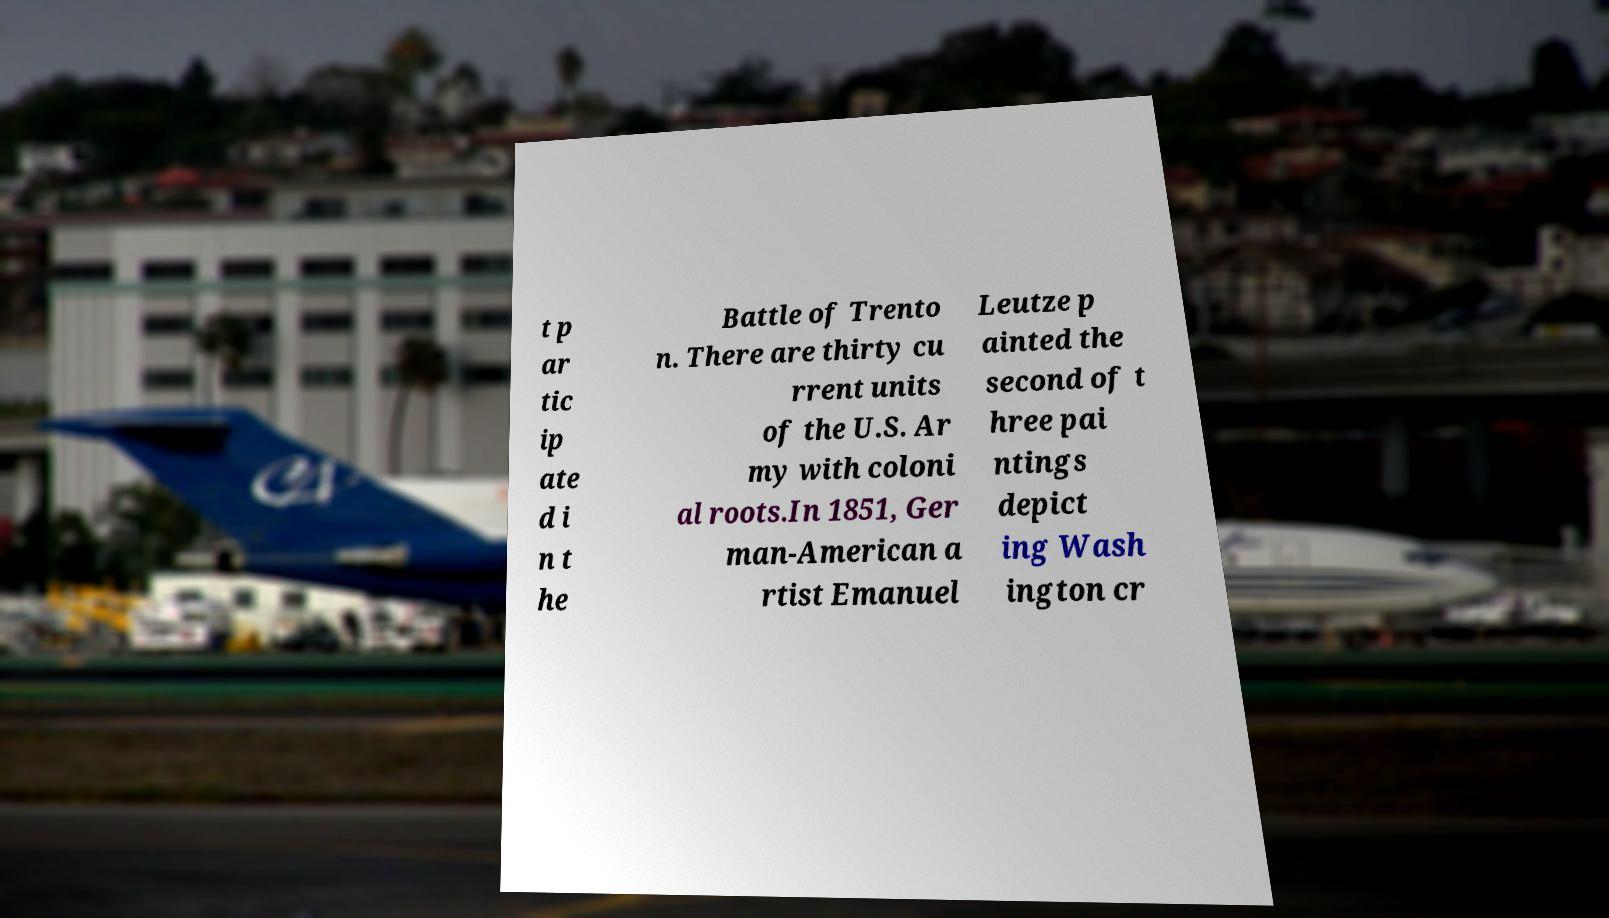Could you assist in decoding the text presented in this image and type it out clearly? t p ar tic ip ate d i n t he Battle of Trento n. There are thirty cu rrent units of the U.S. Ar my with coloni al roots.In 1851, Ger man-American a rtist Emanuel Leutze p ainted the second of t hree pai ntings depict ing Wash ington cr 